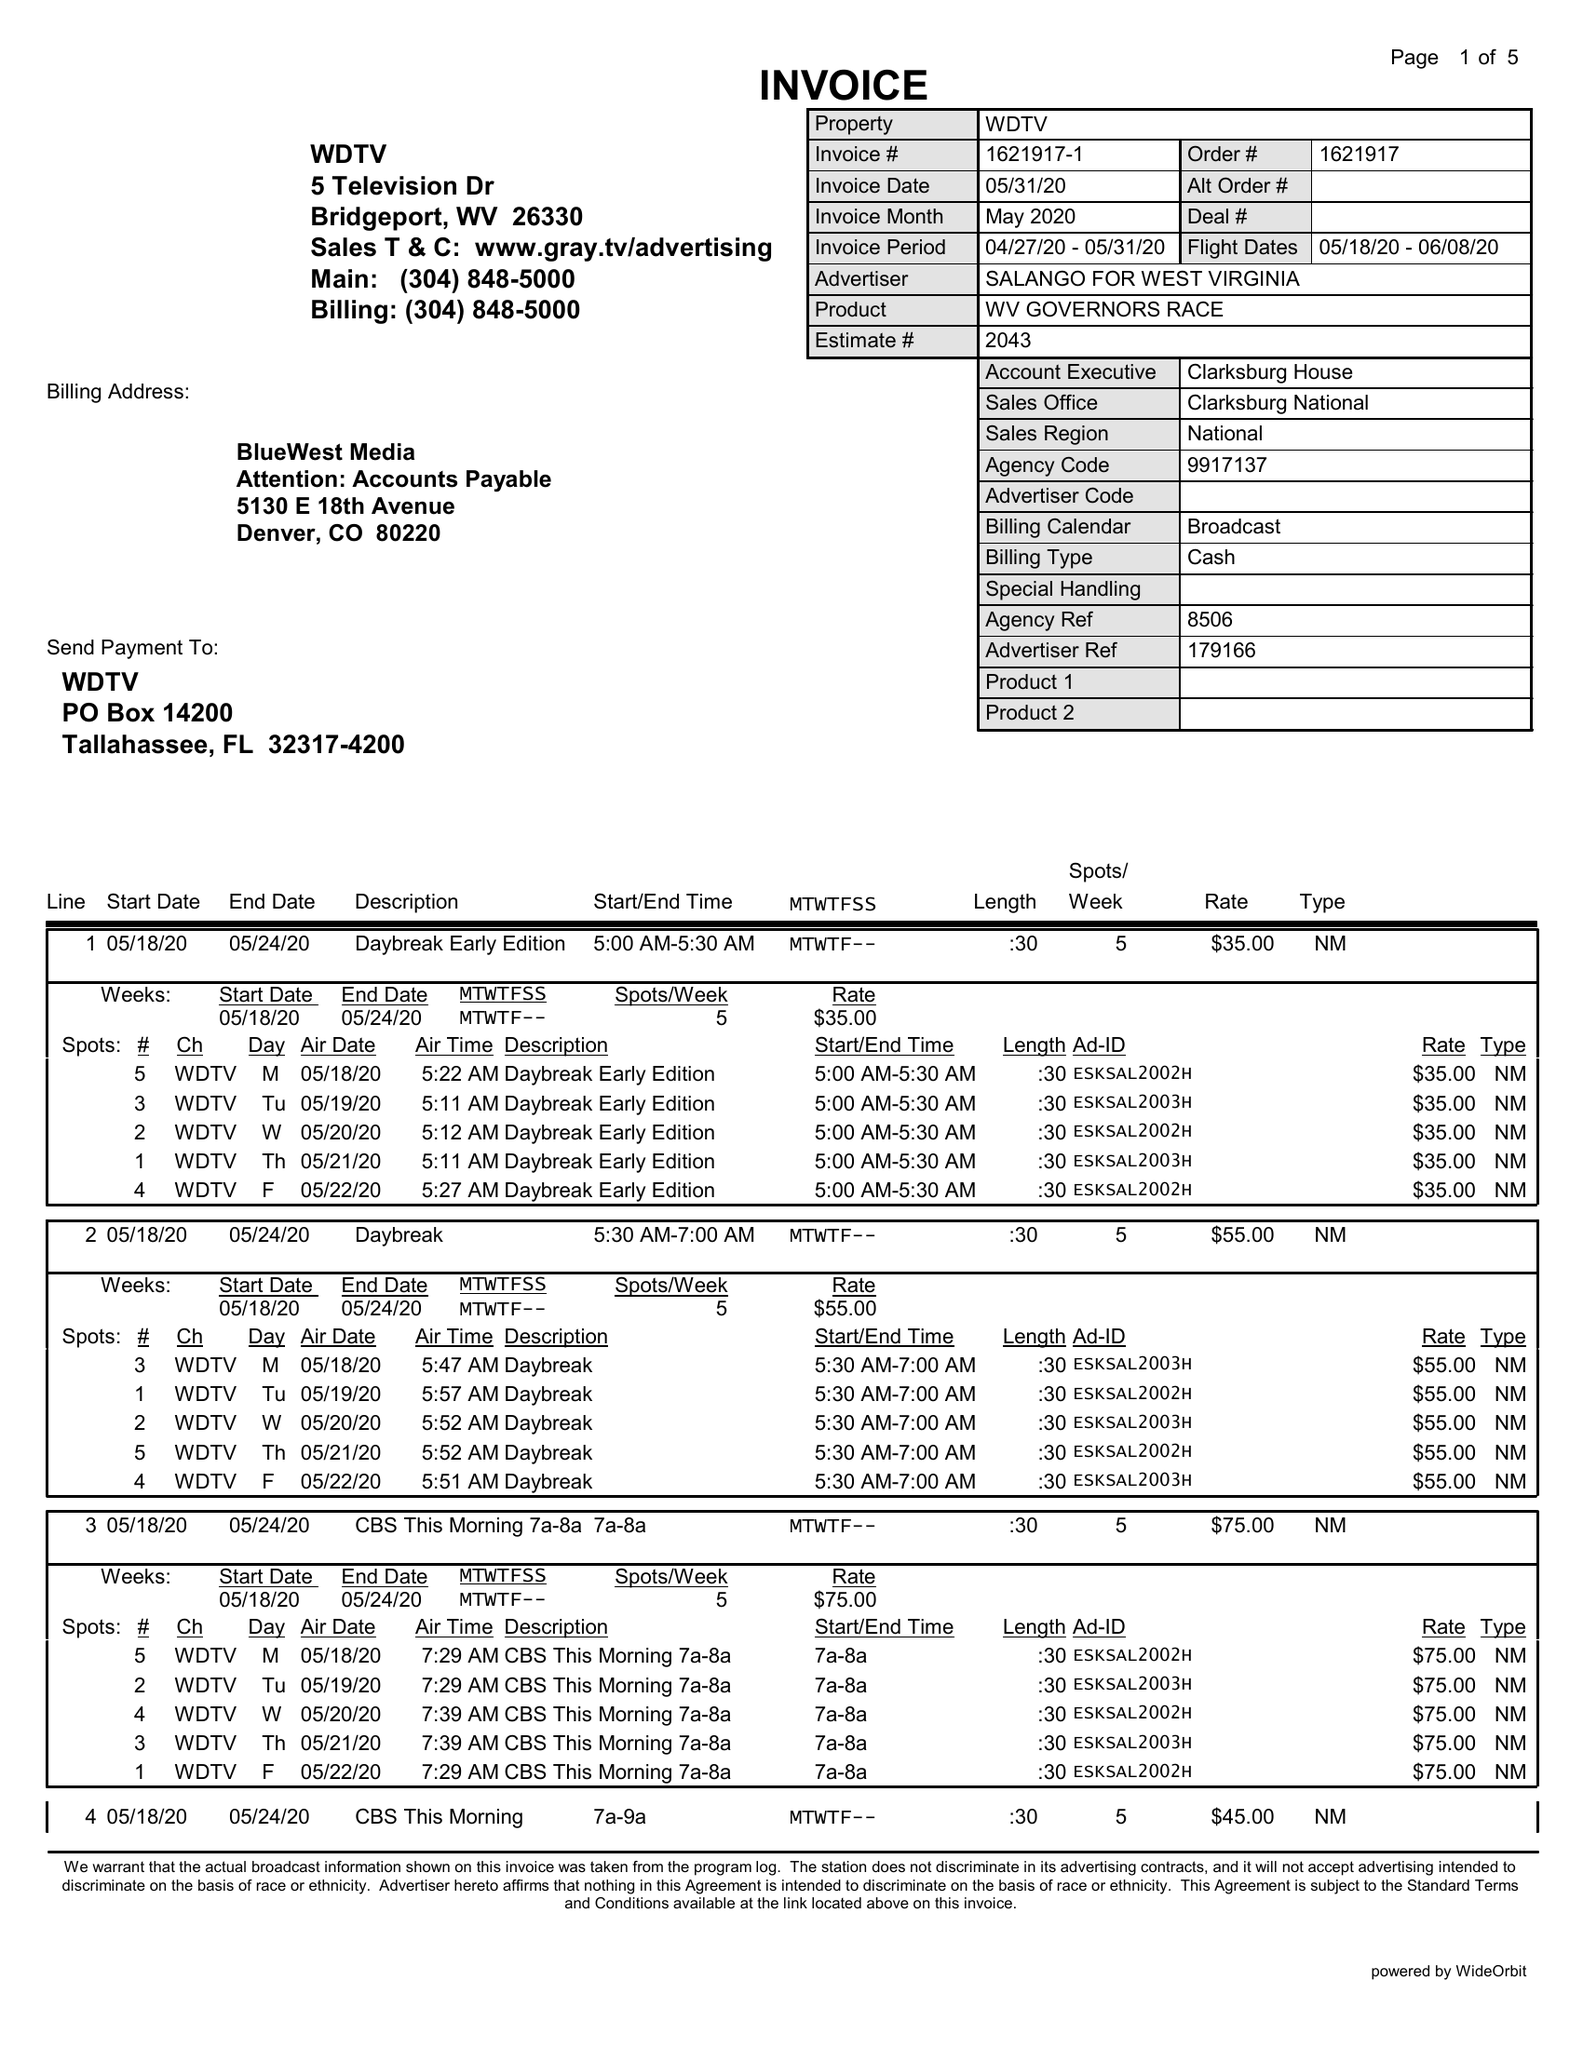What is the value for the gross_amount?
Answer the question using a single word or phrase. 5360.00 